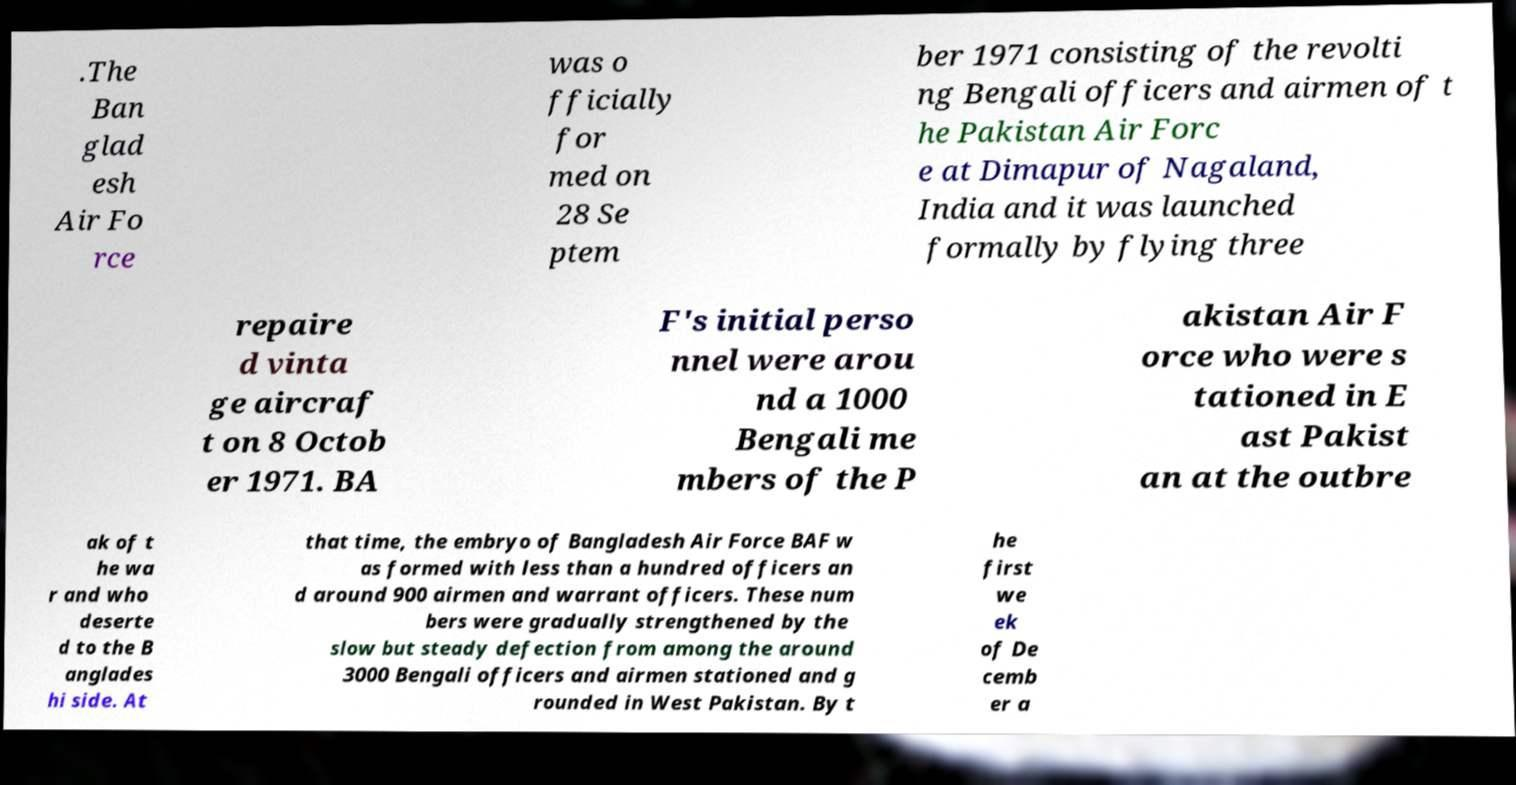Could you extract and type out the text from this image? .The Ban glad esh Air Fo rce was o fficially for med on 28 Se ptem ber 1971 consisting of the revolti ng Bengali officers and airmen of t he Pakistan Air Forc e at Dimapur of Nagaland, India and it was launched formally by flying three repaire d vinta ge aircraf t on 8 Octob er 1971. BA F's initial perso nnel were arou nd a 1000 Bengali me mbers of the P akistan Air F orce who were s tationed in E ast Pakist an at the outbre ak of t he wa r and who deserte d to the B anglades hi side. At that time, the embryo of Bangladesh Air Force BAF w as formed with less than a hundred officers an d around 900 airmen and warrant officers. These num bers were gradually strengthened by the slow but steady defection from among the around 3000 Bengali officers and airmen stationed and g rounded in West Pakistan. By t he first we ek of De cemb er a 